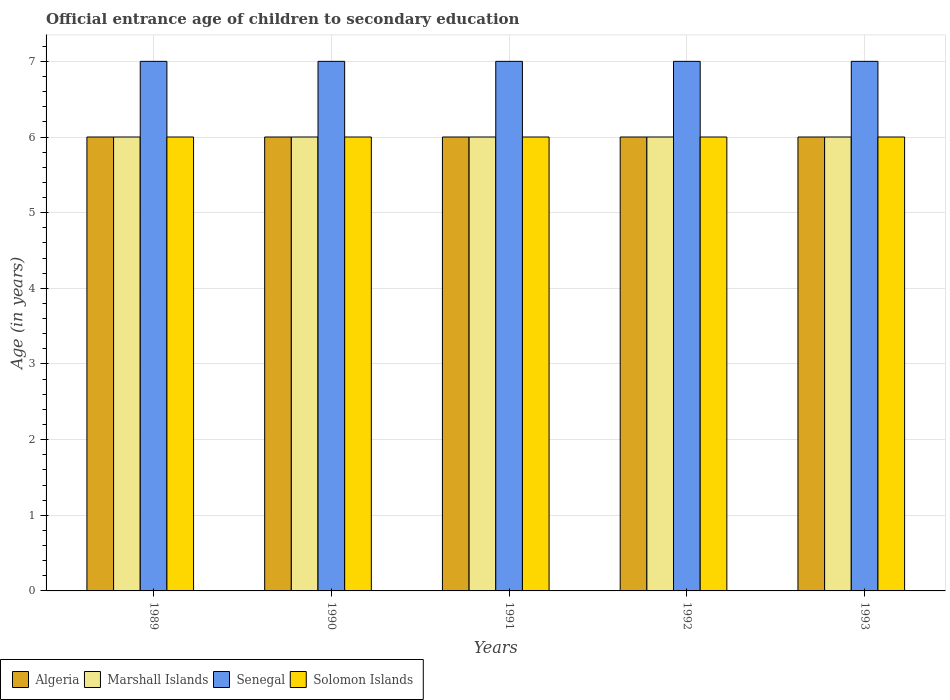How many different coloured bars are there?
Provide a short and direct response. 4. Are the number of bars per tick equal to the number of legend labels?
Your answer should be very brief. Yes. How many bars are there on the 1st tick from the left?
Provide a succinct answer. 4. How many bars are there on the 4th tick from the right?
Offer a terse response. 4. In how many cases, is the number of bars for a given year not equal to the number of legend labels?
Ensure brevity in your answer.  0. What is the secondary school starting age of children in Senegal in 1992?
Provide a short and direct response. 7. Across all years, what is the maximum secondary school starting age of children in Algeria?
Give a very brief answer. 6. What is the total secondary school starting age of children in Senegal in the graph?
Keep it short and to the point. 35. What is the difference between the secondary school starting age of children in Senegal in 1993 and the secondary school starting age of children in Solomon Islands in 1991?
Your answer should be very brief. 1. What is the average secondary school starting age of children in Algeria per year?
Offer a very short reply. 6. In the year 1991, what is the difference between the secondary school starting age of children in Solomon Islands and secondary school starting age of children in Marshall Islands?
Your answer should be compact. 0. What is the difference between the highest and the second highest secondary school starting age of children in Algeria?
Give a very brief answer. 0. What is the difference between the highest and the lowest secondary school starting age of children in Senegal?
Provide a succinct answer. 0. What does the 1st bar from the left in 1991 represents?
Your response must be concise. Algeria. What does the 3rd bar from the right in 1991 represents?
Your response must be concise. Marshall Islands. Is it the case that in every year, the sum of the secondary school starting age of children in Senegal and secondary school starting age of children in Solomon Islands is greater than the secondary school starting age of children in Marshall Islands?
Your answer should be compact. Yes. Are all the bars in the graph horizontal?
Offer a very short reply. No. Does the graph contain any zero values?
Provide a succinct answer. No. Does the graph contain grids?
Provide a succinct answer. Yes. How many legend labels are there?
Offer a very short reply. 4. How are the legend labels stacked?
Your answer should be compact. Horizontal. What is the title of the graph?
Offer a very short reply. Official entrance age of children to secondary education. Does "Burkina Faso" appear as one of the legend labels in the graph?
Ensure brevity in your answer.  No. What is the label or title of the Y-axis?
Keep it short and to the point. Age (in years). What is the Age (in years) of Marshall Islands in 1989?
Keep it short and to the point. 6. What is the Age (in years) in Solomon Islands in 1989?
Give a very brief answer. 6. What is the Age (in years) of Algeria in 1990?
Make the answer very short. 6. What is the Age (in years) of Solomon Islands in 1990?
Offer a terse response. 6. What is the Age (in years) in Marshall Islands in 1991?
Offer a very short reply. 6. What is the Age (in years) in Senegal in 1991?
Make the answer very short. 7. What is the Age (in years) of Marshall Islands in 1992?
Your answer should be very brief. 6. What is the Age (in years) in Senegal in 1992?
Your answer should be very brief. 7. What is the Age (in years) of Solomon Islands in 1992?
Offer a very short reply. 6. What is the Age (in years) of Algeria in 1993?
Ensure brevity in your answer.  6. What is the Age (in years) of Senegal in 1993?
Give a very brief answer. 7. What is the Age (in years) of Solomon Islands in 1993?
Ensure brevity in your answer.  6. Across all years, what is the maximum Age (in years) in Marshall Islands?
Provide a succinct answer. 6. Across all years, what is the maximum Age (in years) in Senegal?
Offer a very short reply. 7. Across all years, what is the maximum Age (in years) in Solomon Islands?
Provide a succinct answer. 6. Across all years, what is the minimum Age (in years) in Senegal?
Give a very brief answer. 7. Across all years, what is the minimum Age (in years) in Solomon Islands?
Offer a terse response. 6. What is the total Age (in years) in Algeria in the graph?
Your response must be concise. 30. What is the total Age (in years) in Marshall Islands in the graph?
Make the answer very short. 30. What is the total Age (in years) in Senegal in the graph?
Offer a very short reply. 35. What is the total Age (in years) in Solomon Islands in the graph?
Give a very brief answer. 30. What is the difference between the Age (in years) in Marshall Islands in 1989 and that in 1990?
Offer a terse response. 0. What is the difference between the Age (in years) in Solomon Islands in 1989 and that in 1990?
Your answer should be compact. 0. What is the difference between the Age (in years) of Algeria in 1989 and that in 1991?
Offer a very short reply. 0. What is the difference between the Age (in years) in Solomon Islands in 1989 and that in 1991?
Keep it short and to the point. 0. What is the difference between the Age (in years) in Marshall Islands in 1989 and that in 1992?
Provide a succinct answer. 0. What is the difference between the Age (in years) of Senegal in 1989 and that in 1992?
Your answer should be compact. 0. What is the difference between the Age (in years) of Solomon Islands in 1989 and that in 1992?
Your answer should be very brief. 0. What is the difference between the Age (in years) in Marshall Islands in 1989 and that in 1993?
Ensure brevity in your answer.  0. What is the difference between the Age (in years) of Senegal in 1989 and that in 1993?
Keep it short and to the point. 0. What is the difference between the Age (in years) in Solomon Islands in 1989 and that in 1993?
Make the answer very short. 0. What is the difference between the Age (in years) of Algeria in 1990 and that in 1991?
Offer a very short reply. 0. What is the difference between the Age (in years) of Algeria in 1990 and that in 1992?
Your answer should be compact. 0. What is the difference between the Age (in years) in Algeria in 1990 and that in 1993?
Provide a short and direct response. 0. What is the difference between the Age (in years) in Senegal in 1990 and that in 1993?
Your answer should be very brief. 0. What is the difference between the Age (in years) of Solomon Islands in 1990 and that in 1993?
Offer a very short reply. 0. What is the difference between the Age (in years) of Senegal in 1991 and that in 1992?
Provide a short and direct response. 0. What is the difference between the Age (in years) in Marshall Islands in 1992 and that in 1993?
Provide a short and direct response. 0. What is the difference between the Age (in years) in Senegal in 1992 and that in 1993?
Make the answer very short. 0. What is the difference between the Age (in years) of Algeria in 1989 and the Age (in years) of Solomon Islands in 1990?
Your answer should be very brief. 0. What is the difference between the Age (in years) of Senegal in 1989 and the Age (in years) of Solomon Islands in 1990?
Give a very brief answer. 1. What is the difference between the Age (in years) in Algeria in 1989 and the Age (in years) in Marshall Islands in 1991?
Keep it short and to the point. 0. What is the difference between the Age (in years) in Algeria in 1989 and the Age (in years) in Senegal in 1991?
Provide a succinct answer. -1. What is the difference between the Age (in years) in Marshall Islands in 1989 and the Age (in years) in Solomon Islands in 1991?
Your answer should be very brief. 0. What is the difference between the Age (in years) in Senegal in 1989 and the Age (in years) in Solomon Islands in 1991?
Provide a succinct answer. 1. What is the difference between the Age (in years) in Marshall Islands in 1989 and the Age (in years) in Solomon Islands in 1992?
Keep it short and to the point. 0. What is the difference between the Age (in years) of Marshall Islands in 1989 and the Age (in years) of Senegal in 1993?
Your response must be concise. -1. What is the difference between the Age (in years) of Senegal in 1989 and the Age (in years) of Solomon Islands in 1993?
Offer a very short reply. 1. What is the difference between the Age (in years) of Algeria in 1990 and the Age (in years) of Marshall Islands in 1991?
Ensure brevity in your answer.  0. What is the difference between the Age (in years) in Algeria in 1990 and the Age (in years) in Senegal in 1991?
Keep it short and to the point. -1. What is the difference between the Age (in years) in Algeria in 1990 and the Age (in years) in Solomon Islands in 1991?
Your answer should be very brief. 0. What is the difference between the Age (in years) in Marshall Islands in 1990 and the Age (in years) in Senegal in 1991?
Provide a short and direct response. -1. What is the difference between the Age (in years) of Marshall Islands in 1990 and the Age (in years) of Solomon Islands in 1991?
Make the answer very short. 0. What is the difference between the Age (in years) of Algeria in 1990 and the Age (in years) of Senegal in 1992?
Your answer should be very brief. -1. What is the difference between the Age (in years) in Marshall Islands in 1990 and the Age (in years) in Solomon Islands in 1992?
Your response must be concise. 0. What is the difference between the Age (in years) of Senegal in 1990 and the Age (in years) of Solomon Islands in 1992?
Offer a very short reply. 1. What is the difference between the Age (in years) of Algeria in 1990 and the Age (in years) of Senegal in 1993?
Your answer should be compact. -1. What is the difference between the Age (in years) in Marshall Islands in 1990 and the Age (in years) in Solomon Islands in 1993?
Ensure brevity in your answer.  0. What is the difference between the Age (in years) in Algeria in 1991 and the Age (in years) in Marshall Islands in 1992?
Your response must be concise. 0. What is the difference between the Age (in years) of Algeria in 1991 and the Age (in years) of Senegal in 1992?
Give a very brief answer. -1. What is the difference between the Age (in years) of Algeria in 1991 and the Age (in years) of Solomon Islands in 1992?
Ensure brevity in your answer.  0. What is the difference between the Age (in years) of Senegal in 1991 and the Age (in years) of Solomon Islands in 1992?
Your answer should be compact. 1. What is the difference between the Age (in years) in Algeria in 1991 and the Age (in years) in Solomon Islands in 1993?
Your answer should be compact. 0. What is the difference between the Age (in years) in Marshall Islands in 1991 and the Age (in years) in Senegal in 1993?
Offer a terse response. -1. What is the difference between the Age (in years) of Marshall Islands in 1991 and the Age (in years) of Solomon Islands in 1993?
Make the answer very short. 0. What is the difference between the Age (in years) in Senegal in 1991 and the Age (in years) in Solomon Islands in 1993?
Provide a short and direct response. 1. What is the difference between the Age (in years) of Algeria in 1992 and the Age (in years) of Solomon Islands in 1993?
Provide a short and direct response. 0. What is the average Age (in years) in Marshall Islands per year?
Provide a succinct answer. 6. What is the average Age (in years) of Senegal per year?
Provide a succinct answer. 7. In the year 1989, what is the difference between the Age (in years) in Marshall Islands and Age (in years) in Senegal?
Make the answer very short. -1. In the year 1989, what is the difference between the Age (in years) of Marshall Islands and Age (in years) of Solomon Islands?
Your response must be concise. 0. In the year 1990, what is the difference between the Age (in years) of Marshall Islands and Age (in years) of Senegal?
Provide a short and direct response. -1. In the year 1990, what is the difference between the Age (in years) in Marshall Islands and Age (in years) in Solomon Islands?
Offer a very short reply. 0. In the year 1990, what is the difference between the Age (in years) in Senegal and Age (in years) in Solomon Islands?
Your answer should be very brief. 1. In the year 1991, what is the difference between the Age (in years) of Algeria and Age (in years) of Senegal?
Offer a terse response. -1. In the year 1991, what is the difference between the Age (in years) in Algeria and Age (in years) in Solomon Islands?
Provide a succinct answer. 0. In the year 1991, what is the difference between the Age (in years) of Marshall Islands and Age (in years) of Solomon Islands?
Give a very brief answer. 0. In the year 1991, what is the difference between the Age (in years) in Senegal and Age (in years) in Solomon Islands?
Provide a succinct answer. 1. In the year 1992, what is the difference between the Age (in years) in Algeria and Age (in years) in Senegal?
Your response must be concise. -1. In the year 1992, what is the difference between the Age (in years) in Algeria and Age (in years) in Solomon Islands?
Your response must be concise. 0. In the year 1992, what is the difference between the Age (in years) of Marshall Islands and Age (in years) of Senegal?
Your response must be concise. -1. In the year 1992, what is the difference between the Age (in years) of Marshall Islands and Age (in years) of Solomon Islands?
Offer a terse response. 0. In the year 1992, what is the difference between the Age (in years) in Senegal and Age (in years) in Solomon Islands?
Your answer should be compact. 1. In the year 1993, what is the difference between the Age (in years) of Algeria and Age (in years) of Marshall Islands?
Your answer should be compact. 0. In the year 1993, what is the difference between the Age (in years) in Algeria and Age (in years) in Senegal?
Make the answer very short. -1. In the year 1993, what is the difference between the Age (in years) of Senegal and Age (in years) of Solomon Islands?
Give a very brief answer. 1. What is the ratio of the Age (in years) in Algeria in 1989 to that in 1990?
Make the answer very short. 1. What is the ratio of the Age (in years) of Senegal in 1989 to that in 1990?
Provide a short and direct response. 1. What is the ratio of the Age (in years) in Solomon Islands in 1989 to that in 1990?
Your answer should be compact. 1. What is the ratio of the Age (in years) in Algeria in 1989 to that in 1991?
Provide a succinct answer. 1. What is the ratio of the Age (in years) of Senegal in 1989 to that in 1992?
Make the answer very short. 1. What is the ratio of the Age (in years) of Solomon Islands in 1989 to that in 1992?
Give a very brief answer. 1. What is the ratio of the Age (in years) of Algeria in 1989 to that in 1993?
Your answer should be compact. 1. What is the ratio of the Age (in years) of Marshall Islands in 1989 to that in 1993?
Make the answer very short. 1. What is the ratio of the Age (in years) in Solomon Islands in 1989 to that in 1993?
Provide a short and direct response. 1. What is the ratio of the Age (in years) of Algeria in 1990 to that in 1991?
Ensure brevity in your answer.  1. What is the ratio of the Age (in years) of Senegal in 1990 to that in 1991?
Your answer should be very brief. 1. What is the ratio of the Age (in years) of Solomon Islands in 1990 to that in 1991?
Ensure brevity in your answer.  1. What is the ratio of the Age (in years) of Marshall Islands in 1990 to that in 1992?
Your response must be concise. 1. What is the ratio of the Age (in years) of Solomon Islands in 1990 to that in 1992?
Provide a short and direct response. 1. What is the ratio of the Age (in years) in Algeria in 1991 to that in 1992?
Your answer should be compact. 1. What is the ratio of the Age (in years) of Senegal in 1991 to that in 1992?
Provide a short and direct response. 1. What is the ratio of the Age (in years) in Algeria in 1991 to that in 1993?
Offer a terse response. 1. What is the ratio of the Age (in years) in Marshall Islands in 1991 to that in 1993?
Provide a succinct answer. 1. What is the ratio of the Age (in years) in Marshall Islands in 1992 to that in 1993?
Your answer should be very brief. 1. What is the difference between the highest and the second highest Age (in years) of Algeria?
Offer a terse response. 0. What is the difference between the highest and the second highest Age (in years) of Marshall Islands?
Make the answer very short. 0. What is the difference between the highest and the second highest Age (in years) in Senegal?
Provide a short and direct response. 0. What is the difference between the highest and the lowest Age (in years) of Solomon Islands?
Offer a very short reply. 0. 